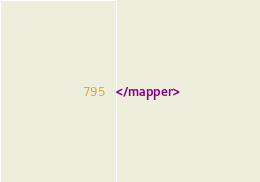<code> <loc_0><loc_0><loc_500><loc_500><_XML_></mapper>
</code> 